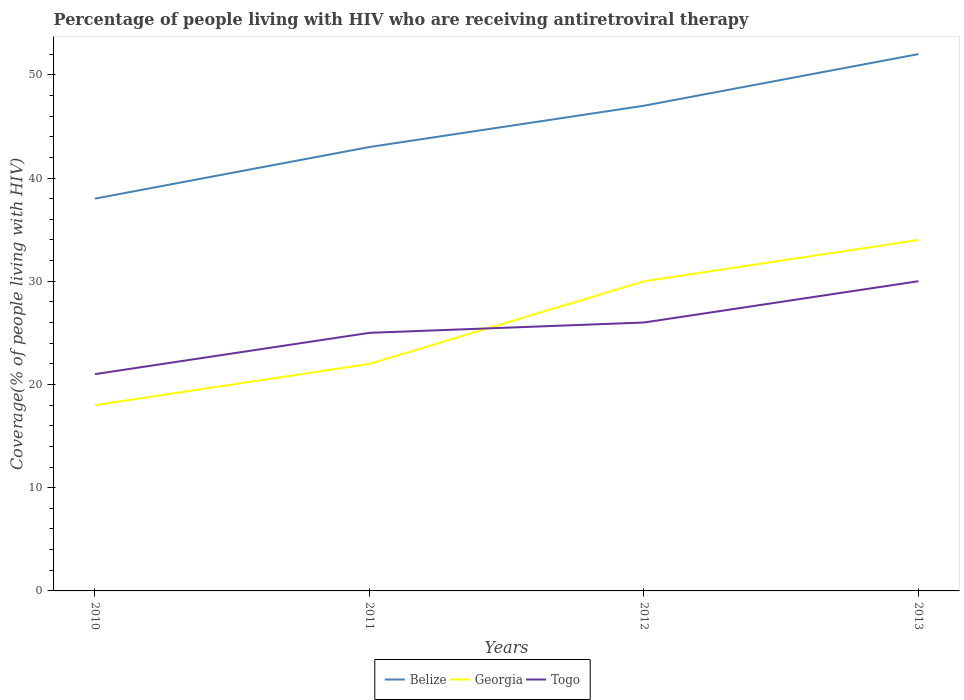Across all years, what is the maximum percentage of the HIV infected people who are receiving antiretroviral therapy in Togo?
Your answer should be compact. 21. In which year was the percentage of the HIV infected people who are receiving antiretroviral therapy in Georgia maximum?
Ensure brevity in your answer.  2010. What is the total percentage of the HIV infected people who are receiving antiretroviral therapy in Belize in the graph?
Your answer should be compact. -4. What is the difference between the highest and the second highest percentage of the HIV infected people who are receiving antiretroviral therapy in Togo?
Your answer should be compact. 9. Is the percentage of the HIV infected people who are receiving antiretroviral therapy in Belize strictly greater than the percentage of the HIV infected people who are receiving antiretroviral therapy in Georgia over the years?
Your answer should be compact. No. How many lines are there?
Provide a short and direct response. 3. How many years are there in the graph?
Offer a terse response. 4. Are the values on the major ticks of Y-axis written in scientific E-notation?
Your answer should be compact. No. Where does the legend appear in the graph?
Ensure brevity in your answer.  Bottom center. How many legend labels are there?
Your response must be concise. 3. How are the legend labels stacked?
Ensure brevity in your answer.  Horizontal. What is the title of the graph?
Your answer should be very brief. Percentage of people living with HIV who are receiving antiretroviral therapy. What is the label or title of the Y-axis?
Your answer should be compact. Coverage(% of people living with HIV). What is the Coverage(% of people living with HIV) in Belize in 2011?
Offer a very short reply. 43. What is the Coverage(% of people living with HIV) in Georgia in 2011?
Offer a terse response. 22. What is the Coverage(% of people living with HIV) of Togo in 2012?
Make the answer very short. 26. Across all years, what is the maximum Coverage(% of people living with HIV) in Belize?
Keep it short and to the point. 52. Across all years, what is the maximum Coverage(% of people living with HIV) in Togo?
Give a very brief answer. 30. Across all years, what is the minimum Coverage(% of people living with HIV) in Belize?
Offer a terse response. 38. What is the total Coverage(% of people living with HIV) in Belize in the graph?
Your answer should be compact. 180. What is the total Coverage(% of people living with HIV) in Georgia in the graph?
Offer a very short reply. 104. What is the total Coverage(% of people living with HIV) in Togo in the graph?
Your response must be concise. 102. What is the difference between the Coverage(% of people living with HIV) of Belize in 2010 and that in 2011?
Offer a very short reply. -5. What is the difference between the Coverage(% of people living with HIV) of Georgia in 2010 and that in 2011?
Make the answer very short. -4. What is the difference between the Coverage(% of people living with HIV) of Togo in 2010 and that in 2012?
Provide a short and direct response. -5. What is the difference between the Coverage(% of people living with HIV) in Belize in 2010 and that in 2013?
Make the answer very short. -14. What is the difference between the Coverage(% of people living with HIV) in Togo in 2010 and that in 2013?
Give a very brief answer. -9. What is the difference between the Coverage(% of people living with HIV) in Georgia in 2011 and that in 2012?
Your answer should be very brief. -8. What is the difference between the Coverage(% of people living with HIV) in Togo in 2011 and that in 2012?
Offer a terse response. -1. What is the difference between the Coverage(% of people living with HIV) in Belize in 2012 and that in 2013?
Ensure brevity in your answer.  -5. What is the difference between the Coverage(% of people living with HIV) of Georgia in 2012 and that in 2013?
Offer a terse response. -4. What is the difference between the Coverage(% of people living with HIV) of Togo in 2012 and that in 2013?
Make the answer very short. -4. What is the difference between the Coverage(% of people living with HIV) of Belize in 2010 and the Coverage(% of people living with HIV) of Georgia in 2011?
Your response must be concise. 16. What is the difference between the Coverage(% of people living with HIV) in Georgia in 2010 and the Coverage(% of people living with HIV) in Togo in 2011?
Make the answer very short. -7. What is the difference between the Coverage(% of people living with HIV) in Belize in 2010 and the Coverage(% of people living with HIV) in Georgia in 2012?
Your answer should be compact. 8. What is the difference between the Coverage(% of people living with HIV) of Belize in 2010 and the Coverage(% of people living with HIV) of Togo in 2013?
Your response must be concise. 8. What is the difference between the Coverage(% of people living with HIV) in Belize in 2011 and the Coverage(% of people living with HIV) in Georgia in 2012?
Give a very brief answer. 13. What is the difference between the Coverage(% of people living with HIV) in Georgia in 2011 and the Coverage(% of people living with HIV) in Togo in 2013?
Keep it short and to the point. -8. What is the difference between the Coverage(% of people living with HIV) in Belize in 2012 and the Coverage(% of people living with HIV) in Georgia in 2013?
Offer a very short reply. 13. What is the difference between the Coverage(% of people living with HIV) of Belize in 2012 and the Coverage(% of people living with HIV) of Togo in 2013?
Your answer should be very brief. 17. What is the difference between the Coverage(% of people living with HIV) in Georgia in 2012 and the Coverage(% of people living with HIV) in Togo in 2013?
Your response must be concise. 0. What is the average Coverage(% of people living with HIV) in Georgia per year?
Provide a short and direct response. 26. In the year 2010, what is the difference between the Coverage(% of people living with HIV) in Belize and Coverage(% of people living with HIV) in Georgia?
Your answer should be compact. 20. In the year 2010, what is the difference between the Coverage(% of people living with HIV) of Belize and Coverage(% of people living with HIV) of Togo?
Give a very brief answer. 17. In the year 2011, what is the difference between the Coverage(% of people living with HIV) of Georgia and Coverage(% of people living with HIV) of Togo?
Keep it short and to the point. -3. In the year 2012, what is the difference between the Coverage(% of people living with HIV) of Belize and Coverage(% of people living with HIV) of Georgia?
Provide a short and direct response. 17. In the year 2012, what is the difference between the Coverage(% of people living with HIV) of Georgia and Coverage(% of people living with HIV) of Togo?
Offer a terse response. 4. What is the ratio of the Coverage(% of people living with HIV) in Belize in 2010 to that in 2011?
Give a very brief answer. 0.88. What is the ratio of the Coverage(% of people living with HIV) of Georgia in 2010 to that in 2011?
Provide a short and direct response. 0.82. What is the ratio of the Coverage(% of people living with HIV) in Togo in 2010 to that in 2011?
Give a very brief answer. 0.84. What is the ratio of the Coverage(% of people living with HIV) in Belize in 2010 to that in 2012?
Provide a short and direct response. 0.81. What is the ratio of the Coverage(% of people living with HIV) of Georgia in 2010 to that in 2012?
Offer a very short reply. 0.6. What is the ratio of the Coverage(% of people living with HIV) of Togo in 2010 to that in 2012?
Your answer should be very brief. 0.81. What is the ratio of the Coverage(% of people living with HIV) in Belize in 2010 to that in 2013?
Give a very brief answer. 0.73. What is the ratio of the Coverage(% of people living with HIV) of Georgia in 2010 to that in 2013?
Your response must be concise. 0.53. What is the ratio of the Coverage(% of people living with HIV) of Belize in 2011 to that in 2012?
Your response must be concise. 0.91. What is the ratio of the Coverage(% of people living with HIV) of Georgia in 2011 to that in 2012?
Make the answer very short. 0.73. What is the ratio of the Coverage(% of people living with HIV) of Togo in 2011 to that in 2012?
Keep it short and to the point. 0.96. What is the ratio of the Coverage(% of people living with HIV) in Belize in 2011 to that in 2013?
Your answer should be very brief. 0.83. What is the ratio of the Coverage(% of people living with HIV) of Georgia in 2011 to that in 2013?
Make the answer very short. 0.65. What is the ratio of the Coverage(% of people living with HIV) in Belize in 2012 to that in 2013?
Your answer should be very brief. 0.9. What is the ratio of the Coverage(% of people living with HIV) of Georgia in 2012 to that in 2013?
Provide a succinct answer. 0.88. What is the ratio of the Coverage(% of people living with HIV) of Togo in 2012 to that in 2013?
Ensure brevity in your answer.  0.87. What is the difference between the highest and the second highest Coverage(% of people living with HIV) in Georgia?
Your answer should be compact. 4. What is the difference between the highest and the second highest Coverage(% of people living with HIV) in Togo?
Offer a terse response. 4. What is the difference between the highest and the lowest Coverage(% of people living with HIV) in Belize?
Your response must be concise. 14. What is the difference between the highest and the lowest Coverage(% of people living with HIV) of Georgia?
Provide a succinct answer. 16. What is the difference between the highest and the lowest Coverage(% of people living with HIV) of Togo?
Ensure brevity in your answer.  9. 